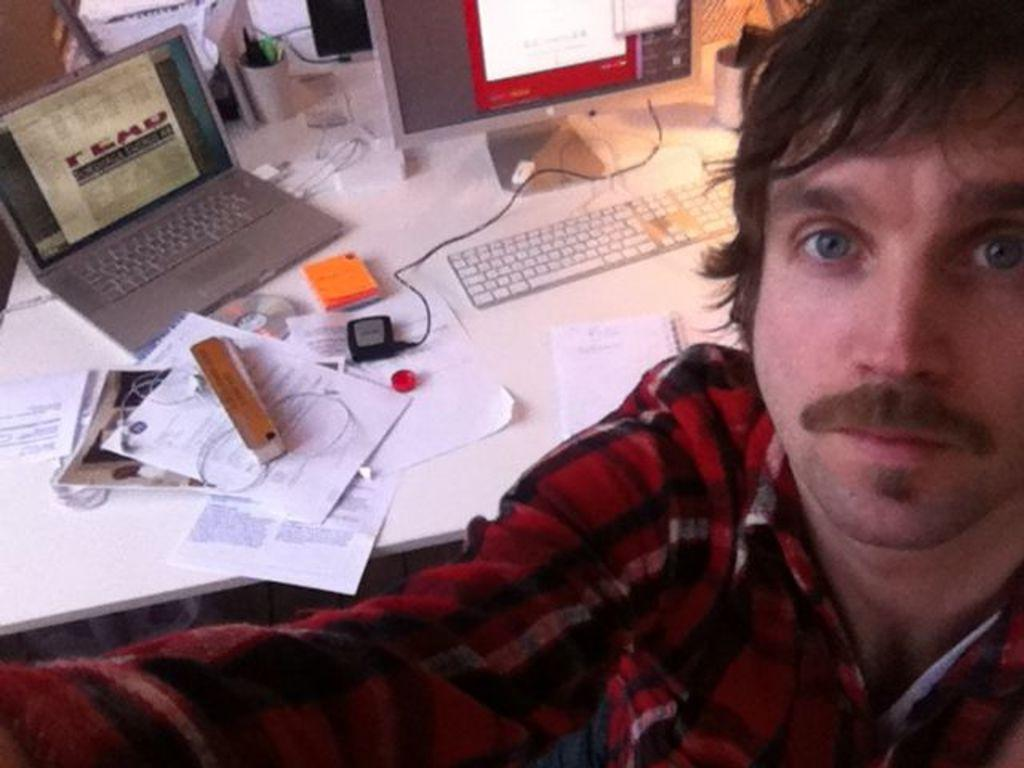Who is present in the image? There is a man in the image. What is the man using in the image? The man is using a monitor, keyboard, and laptop on the table. What else is on the table in the image? There are papers, a box, and a cable on the table. What type of army base can be seen in the image? There is no army base present in the image; it features a man using a monitor, keyboard, and laptop on a table. What smell is coming from the box in the image? There is no mention of a smell or any indication that the box contains anything that would produce a smell in the image. 